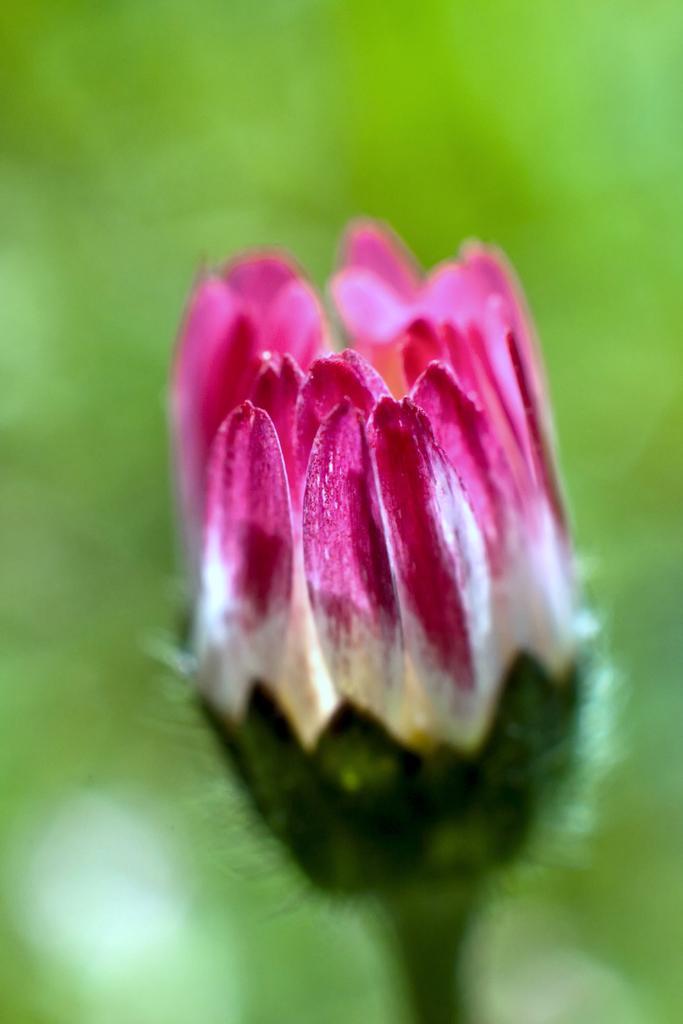Please provide a concise description of this image. This is a zoomed in picture. In the foreground we can see a pink and white color flower. The background of the image is green in color and the background is blurry. 